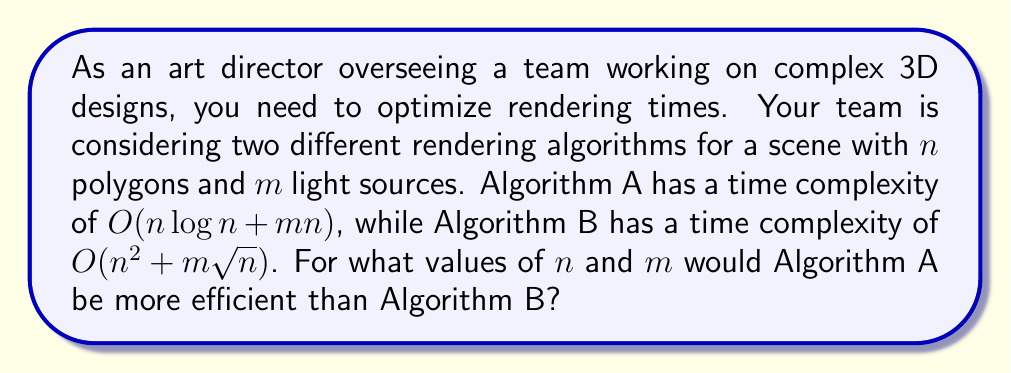Could you help me with this problem? To determine when Algorithm A is more efficient than Algorithm B, we need to compare their time complexities:

1) Algorithm A: $O(n \log n + m n)$
2) Algorithm B: $O(n^2 + m \sqrt{n})$

Algorithm A will be more efficient when its time complexity is asymptotically smaller than that of Algorithm B. To find this, we need to solve the inequality:

$$(n \log n + m n) < (n^2 + m \sqrt{n})$$

Let's consider two cases:

Case 1: When $m$ is small relative to $n$
In this case, the dominant terms will be $n \log n$ for Algorithm A and $n^2$ for Algorithm B. We know that $n \log n < n^2$ for sufficiently large $n$ (specifically, when $n > 2^e \approx 7.39$). So, for small $m$ and large $n$, Algorithm A will always be more efficient.

Case 2: When $m$ is large relative to $n$
In this case, we need to compare $m n$ and $m \sqrt{n}$. Algorithm A will be more efficient when:

$$m n < m \sqrt{n}$$
$$n < \sqrt{n}$$
$$n < n^{\frac{1}{2}}$$
$$n^2 < n$$
$$n < 1$$

However, since $n$ represents the number of polygons, it will always be at least 1. This means that for very large $m$, Algorithm B will eventually become more efficient.

The exact crossover point depends on the relative values of $n$ and $m$. To find it, we can set the two complexities equal:

$$n \log n + m n = n^2 + m \sqrt{n}$$

Solving this equation exactly is complex, but we can approximate that Algorithm A will be more efficient when:

$$m < n^{\frac{3}{2}} / (\sqrt{n} - 1) \approx n$$

This means that as long as the number of light sources ($m$) is less than or approximately equal to the number of polygons ($n$), Algorithm A will generally be more efficient.
Answer: Algorithm A is more efficient when $m < O(n)$, or more precisely, when $m < n^{\frac{3}{2}} / (\sqrt{n} - 1)$. In practical terms for an art director, Algorithm A is likely to be more efficient for most realistic 3D scenes where the number of light sources does not greatly exceed the number of polygons. 